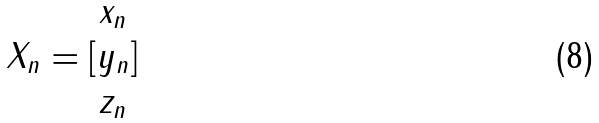Convert formula to latex. <formula><loc_0><loc_0><loc_500><loc_500>X _ { n } = [ \begin{matrix} x _ { n } \\ y _ { n } \\ z _ { n } \end{matrix} ]</formula> 